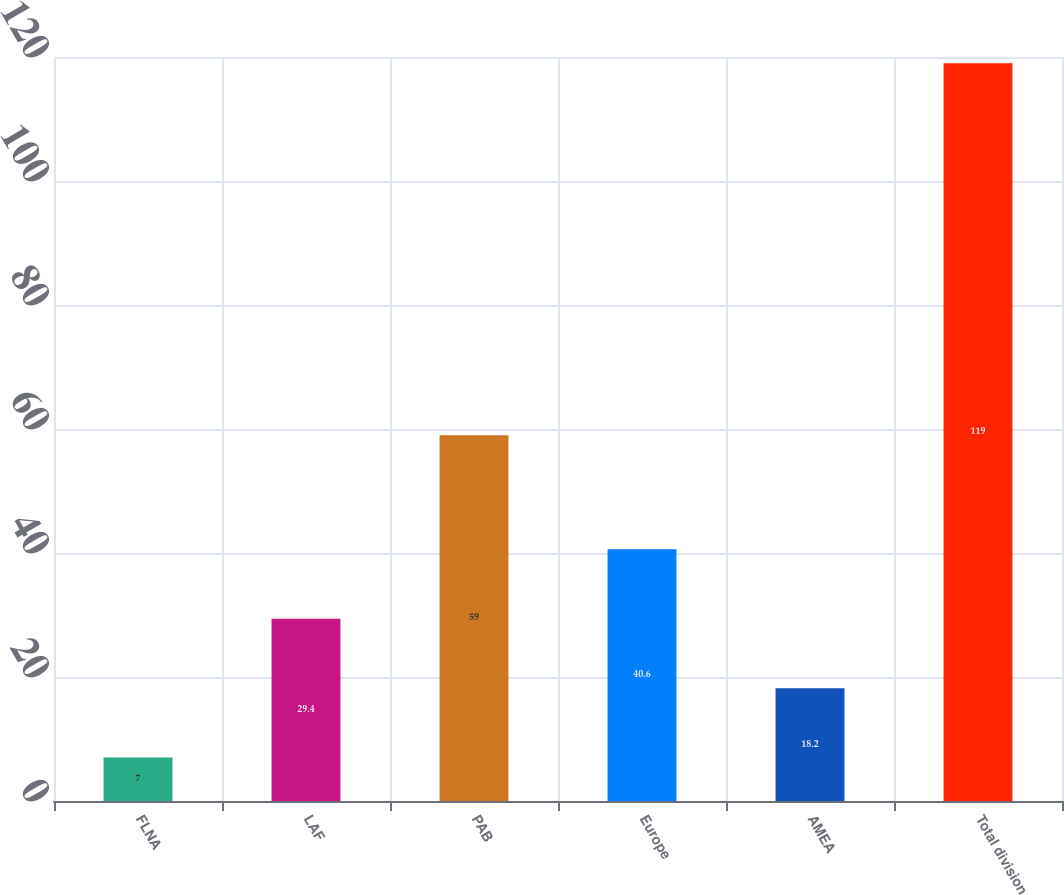<chart> <loc_0><loc_0><loc_500><loc_500><bar_chart><fcel>FLNA<fcel>LAF<fcel>PAB<fcel>Europe<fcel>AMEA<fcel>Total division<nl><fcel>7<fcel>29.4<fcel>59<fcel>40.6<fcel>18.2<fcel>119<nl></chart> 